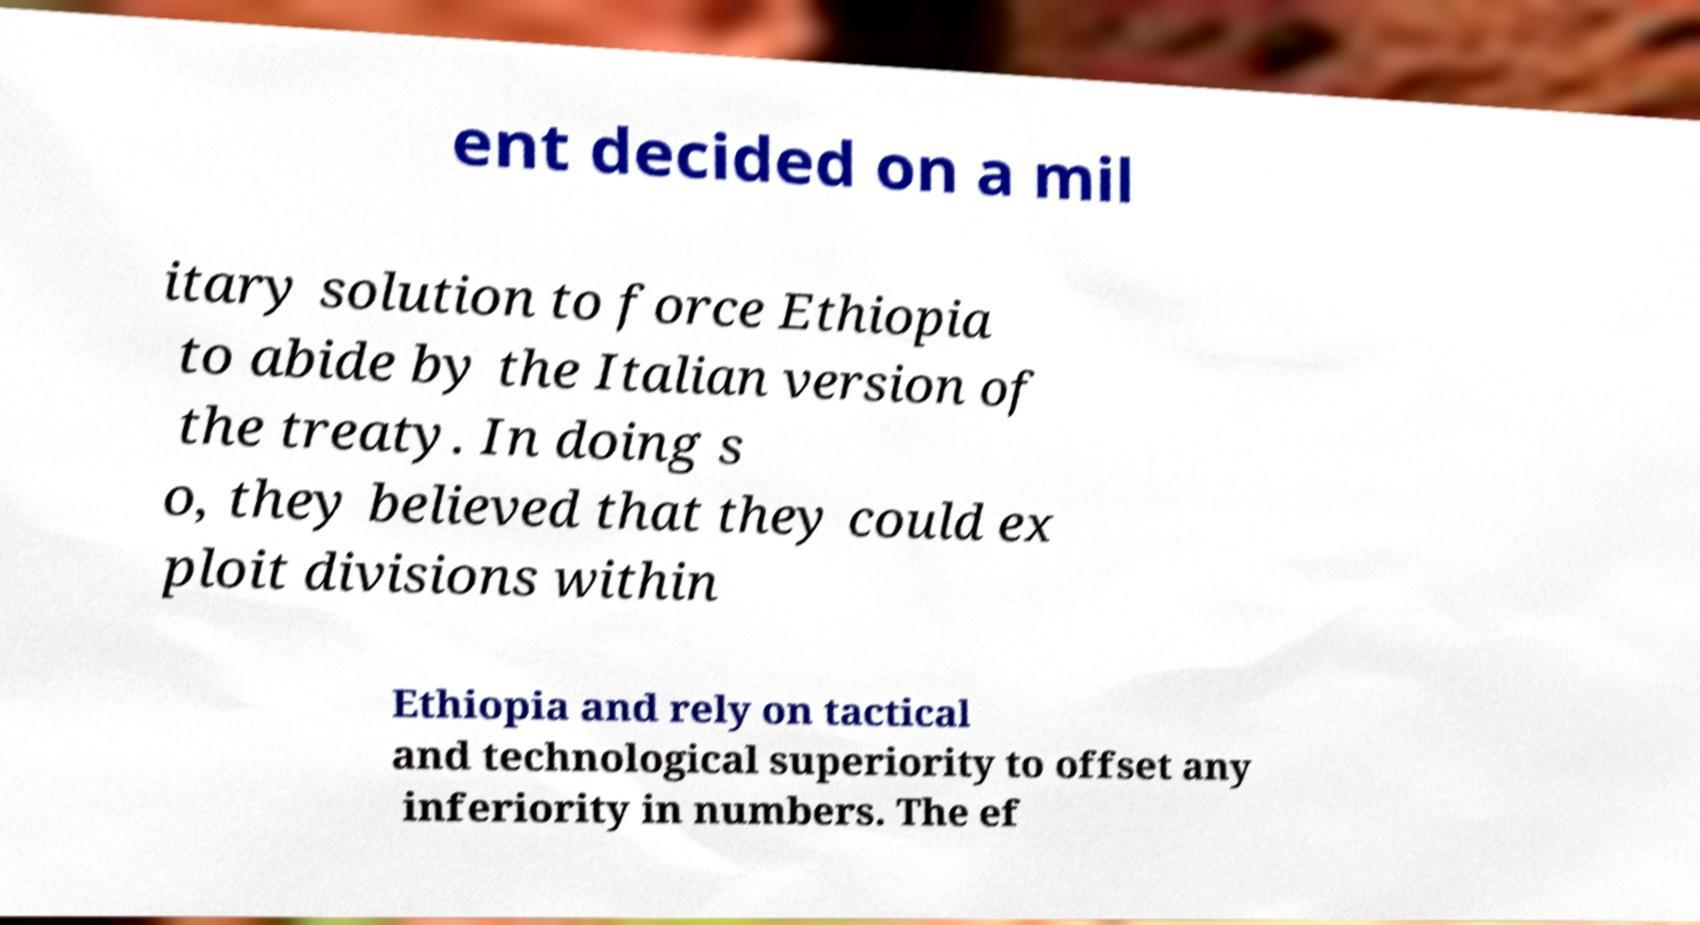Can you read and provide the text displayed in the image?This photo seems to have some interesting text. Can you extract and type it out for me? ent decided on a mil itary solution to force Ethiopia to abide by the Italian version of the treaty. In doing s o, they believed that they could ex ploit divisions within Ethiopia and rely on tactical and technological superiority to offset any inferiority in numbers. The ef 